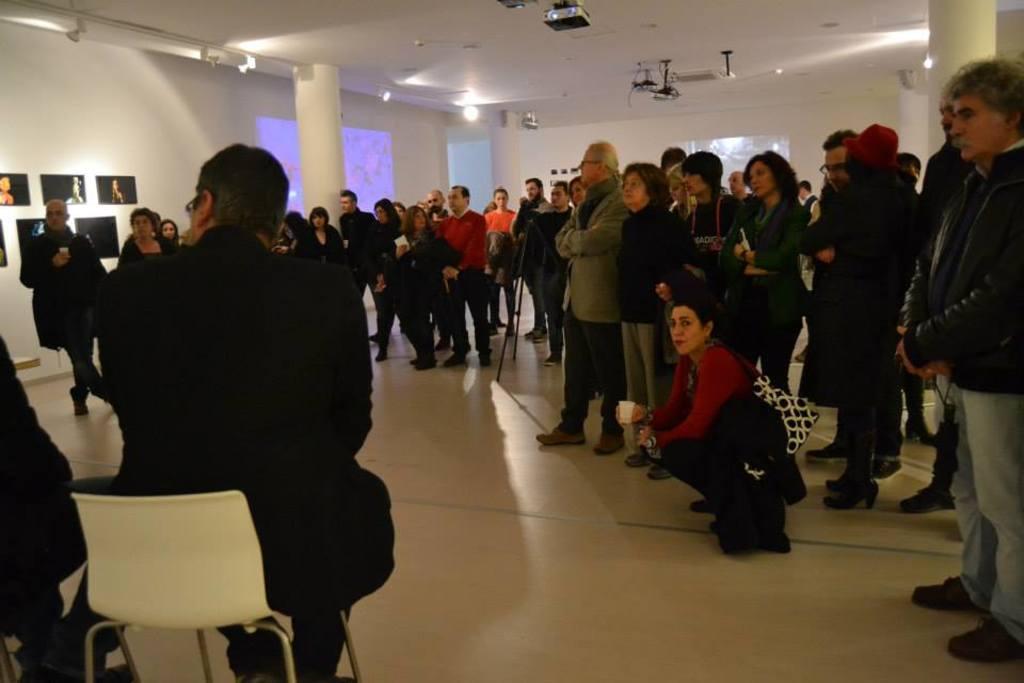In one or two sentences, can you explain what this image depicts? I can see a man sitting on the chair and group of people standing. Photo frame are attached to the wall. I can see a pillar. These are the projectors which are attached to the rooftop. I can see a woman sitting wearing a handbag. 